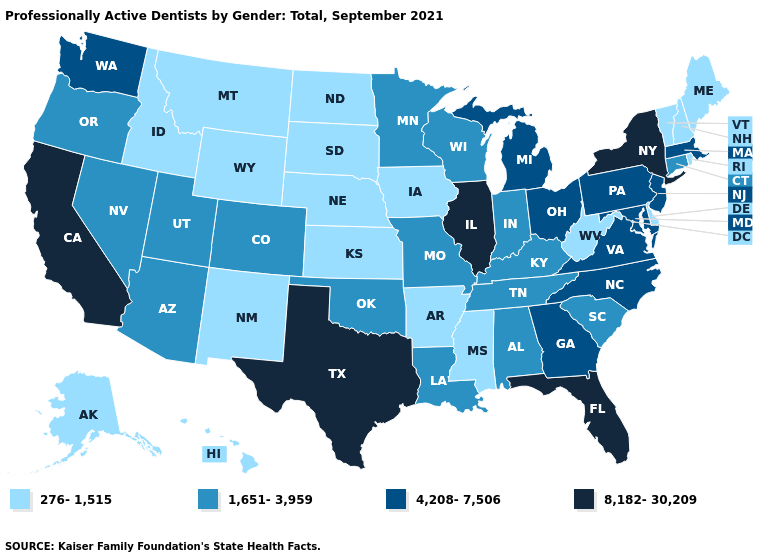What is the value of Ohio?
Short answer required. 4,208-7,506. Does the first symbol in the legend represent the smallest category?
Answer briefly. Yes. Which states have the lowest value in the USA?
Concise answer only. Alaska, Arkansas, Delaware, Hawaii, Idaho, Iowa, Kansas, Maine, Mississippi, Montana, Nebraska, New Hampshire, New Mexico, North Dakota, Rhode Island, South Dakota, Vermont, West Virginia, Wyoming. What is the value of New Mexico?
Short answer required. 276-1,515. What is the value of Massachusetts?
Be succinct. 4,208-7,506. What is the lowest value in the West?
Write a very short answer. 276-1,515. Does Hawaii have a lower value than Missouri?
Answer briefly. Yes. Does the first symbol in the legend represent the smallest category?
Be succinct. Yes. Name the states that have a value in the range 1,651-3,959?
Quick response, please. Alabama, Arizona, Colorado, Connecticut, Indiana, Kentucky, Louisiana, Minnesota, Missouri, Nevada, Oklahoma, Oregon, South Carolina, Tennessee, Utah, Wisconsin. What is the value of Pennsylvania?
Answer briefly. 4,208-7,506. Does Wisconsin have the lowest value in the MidWest?
Answer briefly. No. What is the value of South Carolina?
Answer briefly. 1,651-3,959. What is the value of West Virginia?
Write a very short answer. 276-1,515. Name the states that have a value in the range 1,651-3,959?
Be succinct. Alabama, Arizona, Colorado, Connecticut, Indiana, Kentucky, Louisiana, Minnesota, Missouri, Nevada, Oklahoma, Oregon, South Carolina, Tennessee, Utah, Wisconsin. What is the lowest value in states that border Oklahoma?
Short answer required. 276-1,515. 